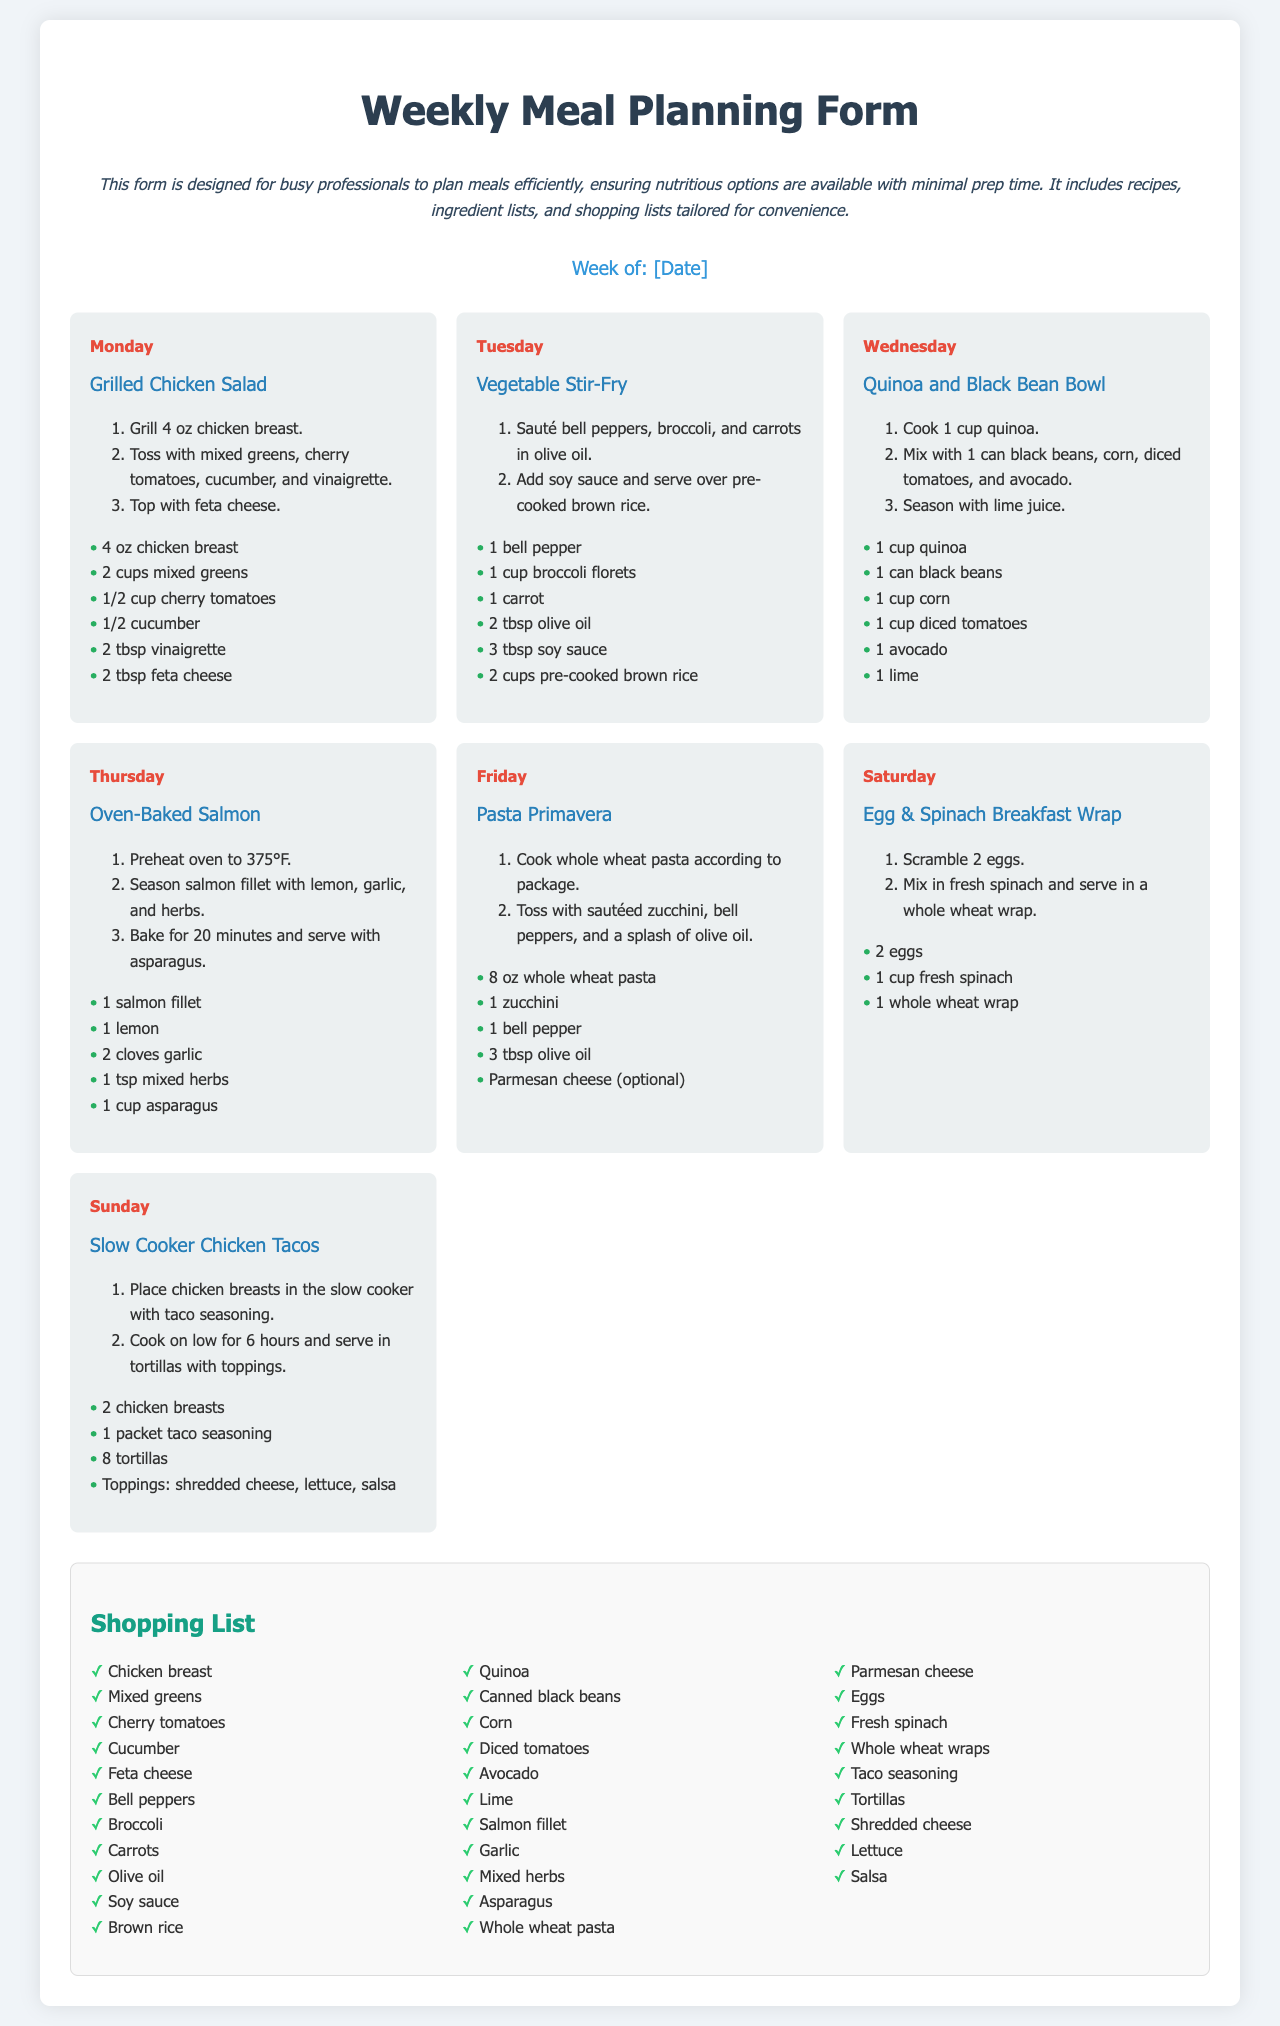what is the title of the document? The title of the document is displayed prominently at the top of the rendered form.
Answer: Weekly Meal Planning Form which day features the Grilled Chicken Salad? The specific day for each meal is noted in the meal cards.
Answer: Monday how many ingredients are listed for the Vegetable Stir-Fry? The number of ingredients can be counted from the list provided under the recipe for each meal.
Answer: 6 what is the cooking method for the Salmon fillet? The cooking method is described in the recipe section for the Oven-Baked Salmon.
Answer: Baked which meal includes Quinoa? The name of the meal is explicitly stated in the title section of each meal card.
Answer: Quinoa and Black Bean Bowl how many hours should the chicken cook in the slow cooker? The cooking duration is specified in the recipe instructions for the Slow Cooker Chicken Tacos.
Answer: 6 hours what is the total number of meals listed for the week? The total number of meal cards indicates the number of meals planned for the week.
Answer: 7 which ingredient is used in both the Quinoa and Black Bean Bowl and the Slow Cooker Chicken Tacos? By cross-referencing the ingredient lists for each meal, common ingredients can be identified.
Answer: Black beans which day of the week is the Egg & Spinach Breakfast Wrap scheduled? Each meal is associated with a specific day mentioned in the meal cards.
Answer: Saturday 